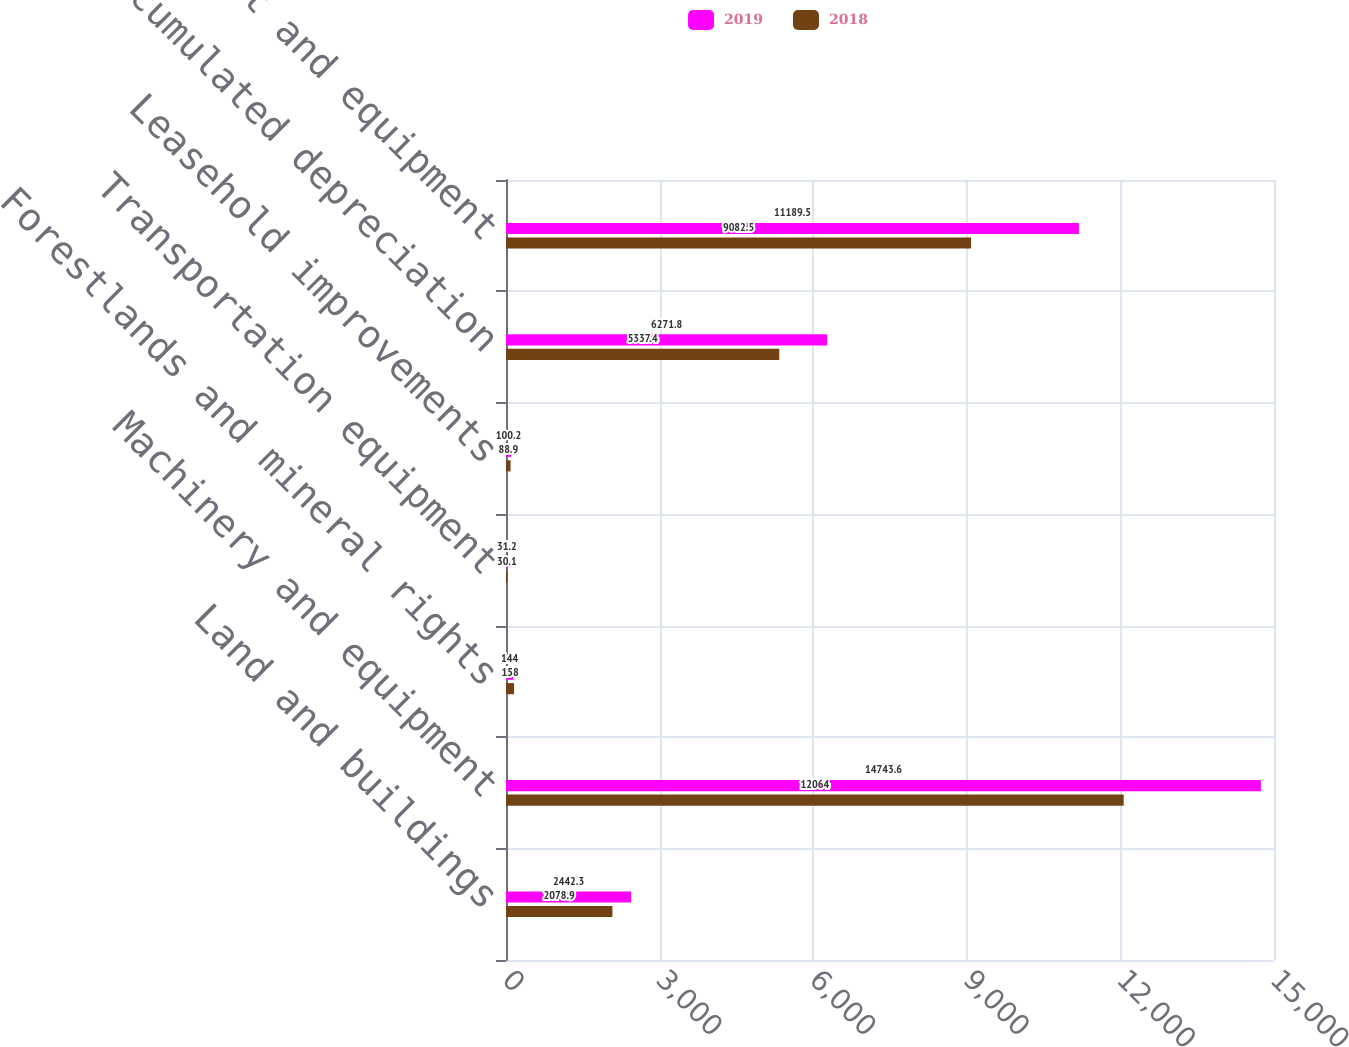<chart> <loc_0><loc_0><loc_500><loc_500><stacked_bar_chart><ecel><fcel>Land and buildings<fcel>Machinery and equipment<fcel>Forestlands and mineral rights<fcel>Transportation equipment<fcel>Leasehold improvements<fcel>Less accumulated depreciation<fcel>Property plant and equipment<nl><fcel>2019<fcel>2442.3<fcel>14743.6<fcel>144<fcel>31.2<fcel>100.2<fcel>6271.8<fcel>11189.5<nl><fcel>2018<fcel>2078.9<fcel>12064<fcel>158<fcel>30.1<fcel>88.9<fcel>5337.4<fcel>9082.5<nl></chart> 